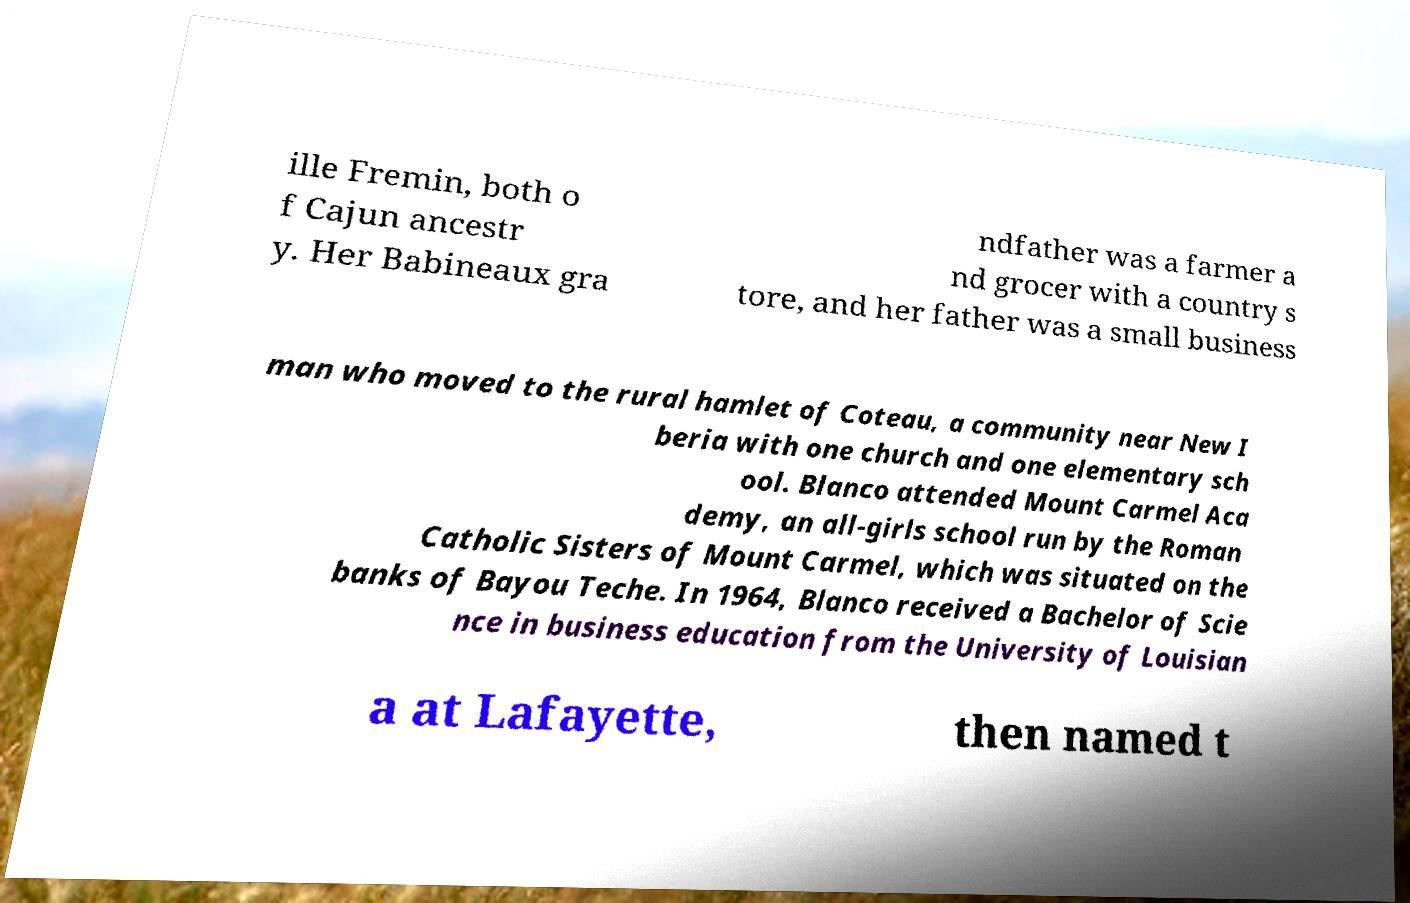Could you assist in decoding the text presented in this image and type it out clearly? ille Fremin, both o f Cajun ancestr y. Her Babineaux gra ndfather was a farmer a nd grocer with a country s tore, and her father was a small business man who moved to the rural hamlet of Coteau, a community near New I beria with one church and one elementary sch ool. Blanco attended Mount Carmel Aca demy, an all-girls school run by the Roman Catholic Sisters of Mount Carmel, which was situated on the banks of Bayou Teche. In 1964, Blanco received a Bachelor of Scie nce in business education from the University of Louisian a at Lafayette, then named t 